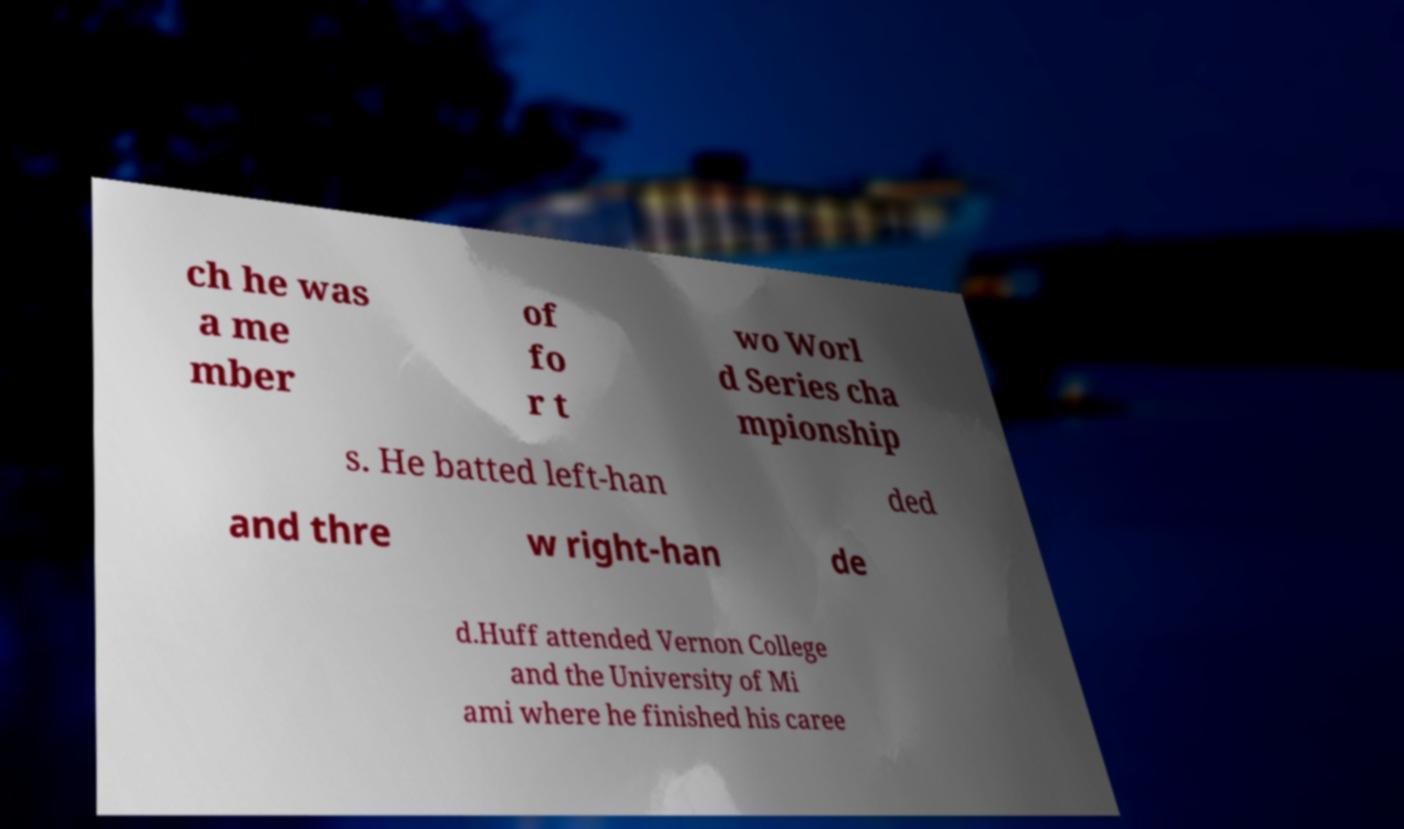Can you accurately transcribe the text from the provided image for me? ch he was a me mber of fo r t wo Worl d Series cha mpionship s. He batted left-han ded and thre w right-han de d.Huff attended Vernon College and the University of Mi ami where he finished his caree 